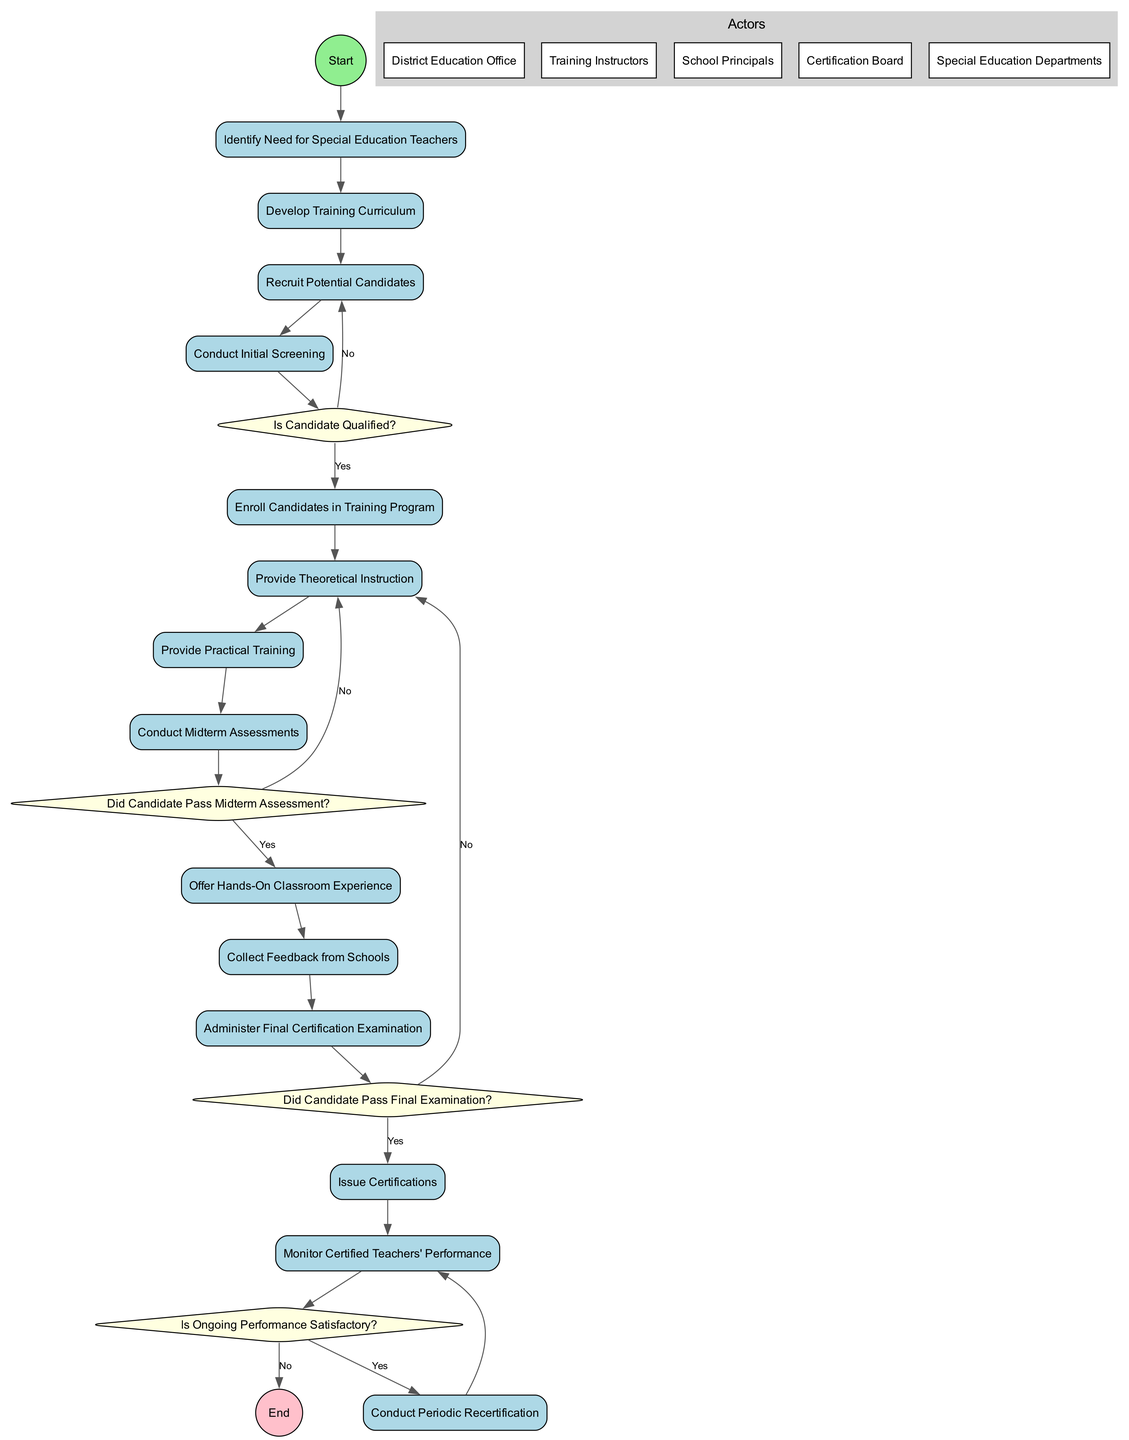What is the number of activities in the diagram? The diagram lists 13 distinct activities, each contributing a specific step in the training and certifying process for special education teachers.
Answer: 13 What is the first activity in the diagram? The first activity is "Identify Need for Special Education Teachers," which serves as the starting point for the entire process.
Answer: Identify Need for Special Education Teachers Which decision follows the "Conduct Initial Screening" activity? After the "Conduct Initial Screening" activity, the diagram indicates a decision point labeled "Is Candidate Qualified?" This decision assesses the qualification of the candidates.
Answer: Is Candidate Qualified? What happens if a candidate does not pass the midterm assessment? If a candidate does not pass the midterm assessment, the flow returns to the "Provide Theoretical Instruction" activity, indicating the candidate will be retrained.
Answer: Provide Theoretical Instruction How many decision points are there in the diagram? The diagram includes 4 decision points, each representing a critical evaluation in the training and certification process for special education teachers.
Answer: 4 What is the last activity before the certification is issued? The final activity before issuance of certifications is "Administer Final Certification Examination," which determines whether candidates qualify for certification.
Answer: Administer Final Certification Examination What occurs after "Issue Certifications"? After "Issue Certifications," the next activity is "Monitor Certified Teachers' Performance," which indicates ongoing oversight of the certified teachers.
Answer: Monitor Certified Teachers' Performance If a candidate passes the final examination, what is the next step? If a candidate passes the final examination, the next step is to issue certifications, thereby formalizing their qualification as special education teachers.
Answer: Issue Certifications What does the decision "Is Ongoing Performance Satisfactory?" evaluate? The decision "Is Ongoing Performance Satisfactory?" evaluates whether the certified teachers are performing satisfactorily after their certification, impacting their continued qualification.
Answer: Ongoing Performance Satisfactory 